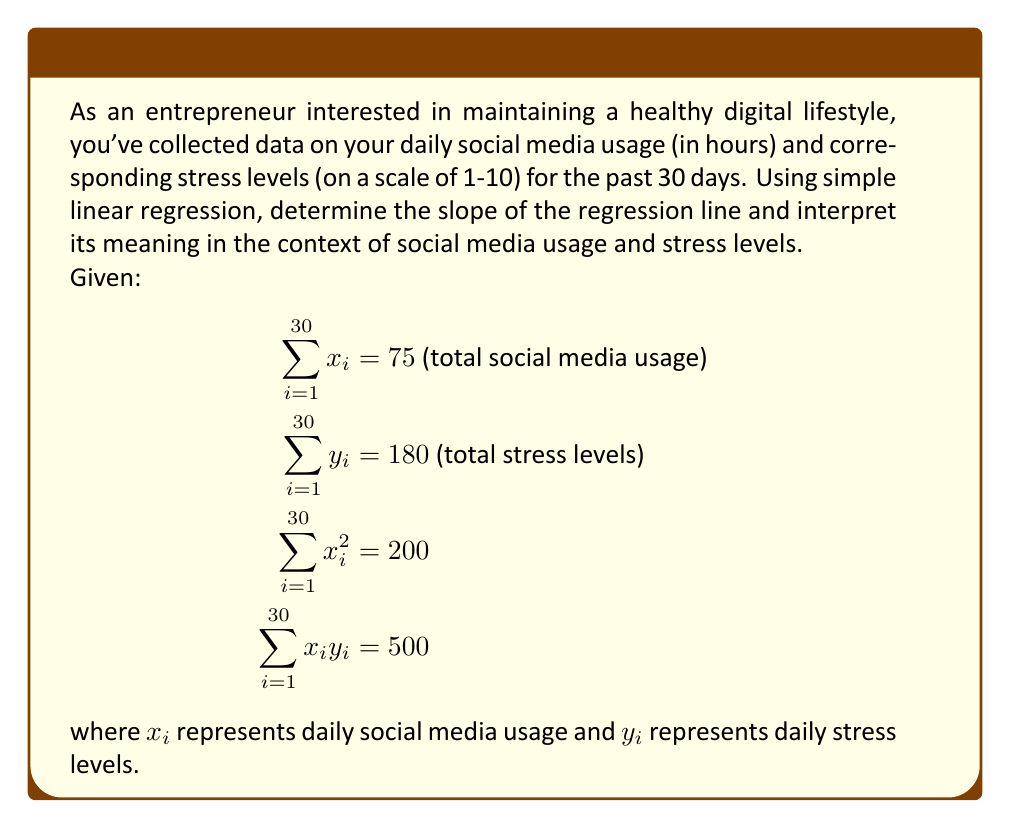Solve this math problem. To solve this problem, we'll use the simple linear regression formula for the slope:

$$\beta_1 = \frac{n\sum x_iy_i - \sum x_i \sum y_i}{n\sum x_i^2 - (\sum x_i)^2}$$

Where:
$n$ = number of data points (30 days)
$\sum x_iy_i$ = sum of the products of x and y
$\sum x_i$ = sum of x values
$\sum y_i$ = sum of y values
$\sum x_i^2$ = sum of squared x values

Let's substitute the given values:

$$\beta_1 = \frac{30(500) - (75)(180)}{30(200) - (75)^2}$$

$$\beta_1 = \frac{15000 - 13500}{6000 - 5625}$$

$$\beta_1 = \frac{1500}{375} = 4$$

The slope of the regression line is 4, which means that for each additional hour of social media usage, the stress level is expected to increase by 4 points on average.

Interpretation: This positive slope indicates a direct relationship between social media usage and stress levels. As an entrepreneur concerned with maintaining a healthy digital lifestyle, this result suggests that reducing social media usage could potentially lead to lower stress levels.
Answer: The slope of the regression line is 4, indicating that each additional hour of daily social media usage is associated with an average increase of 4 points in the stress level scale. 